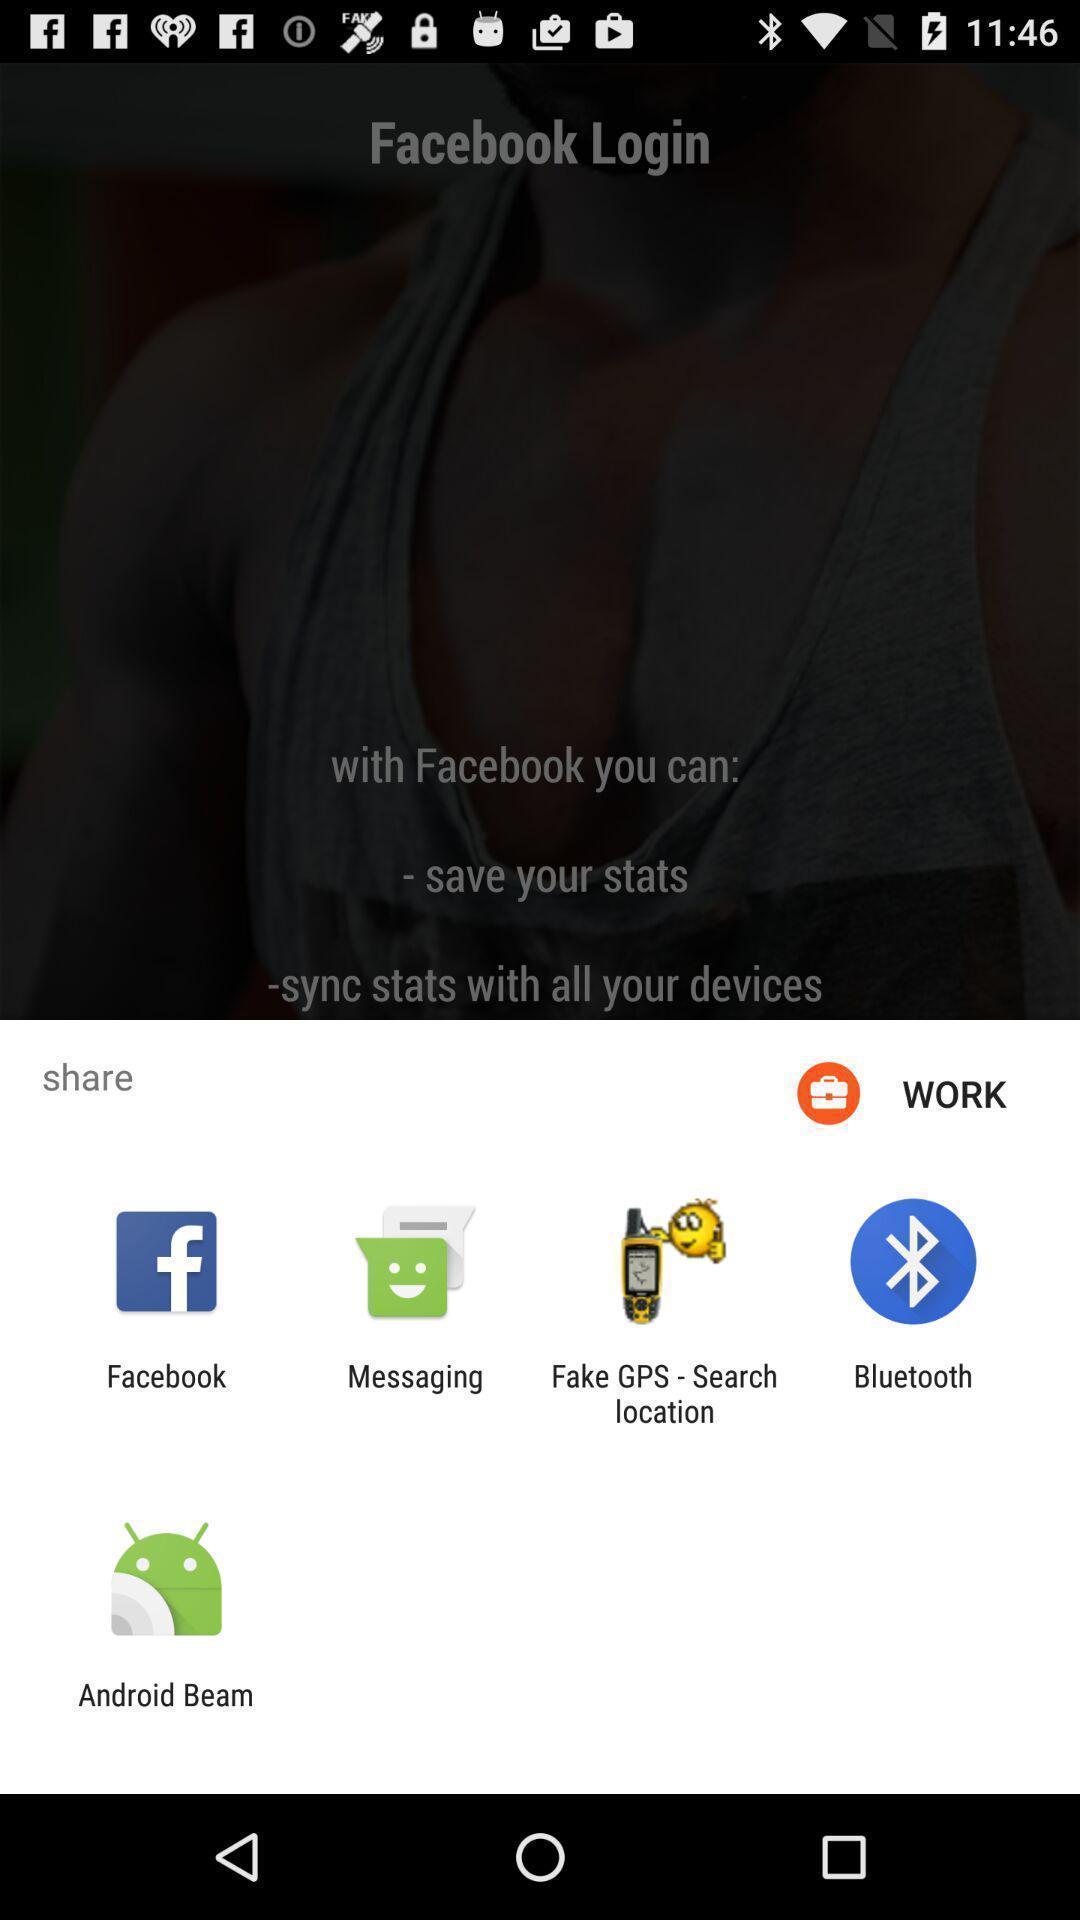Describe the content in this image. Pop-up asking to share with different apps. 